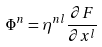<formula> <loc_0><loc_0><loc_500><loc_500>\Phi ^ { n } = \eta ^ { n l } \frac { \partial F } { \partial x ^ { l } }</formula> 